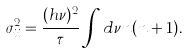<formula> <loc_0><loc_0><loc_500><loc_500>\sigma _ { i i } ^ { 2 } = \frac { ( h \nu ) ^ { 2 } } { \tau } \int d \nu n ( n + 1 ) .</formula> 